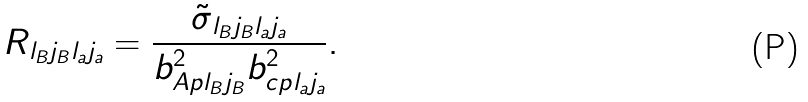Convert formula to latex. <formula><loc_0><loc_0><loc_500><loc_500>R _ { l _ { B } j _ { B } l _ { a } j _ { a } } = \frac { { \tilde { \sigma } } _ { l _ { B } j _ { B } l _ { a } j _ { a } } } { b ^ { 2 } _ { A p l _ { B } j _ { B } } b ^ { 2 } _ { c p l _ { a } j _ { a } } } .</formula> 